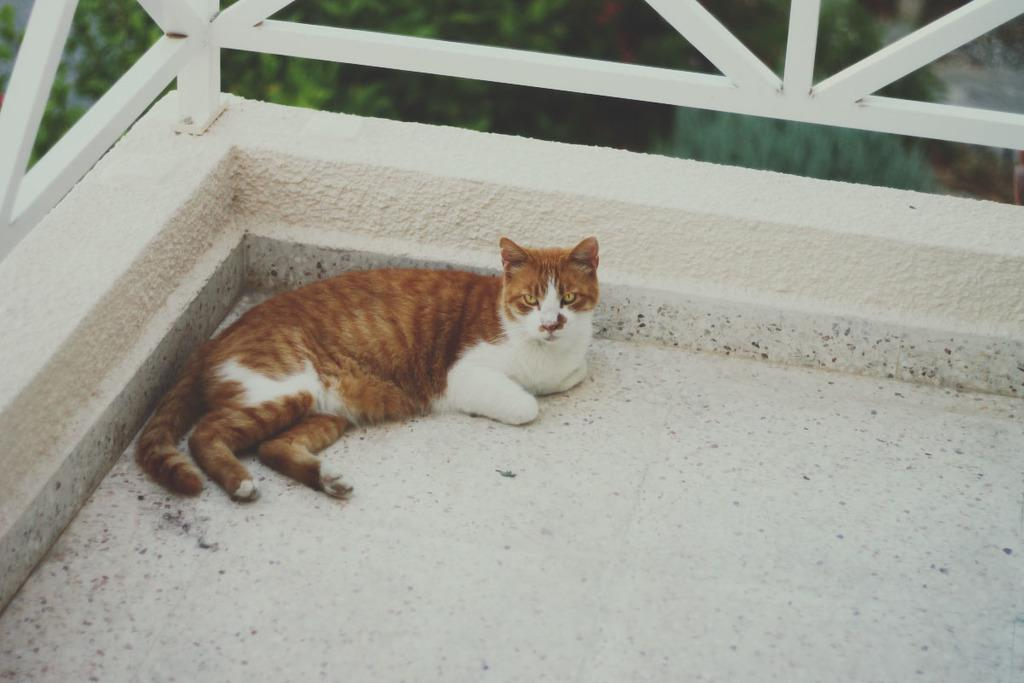What type of animal is on the floor in the image? There is a cat on the floor in the image. What kind of barrier is present in the image? There is a metal fence in the image. What can be seen in the background of the image? There is a tree in the background of the image. What type of structure is visible in the image? There is no specific structure mentioned in the provided facts; the image only contains a cat, a metal fence, and a tree in the background. What kind of sign can be seen in the image? There is no sign present in the image. 